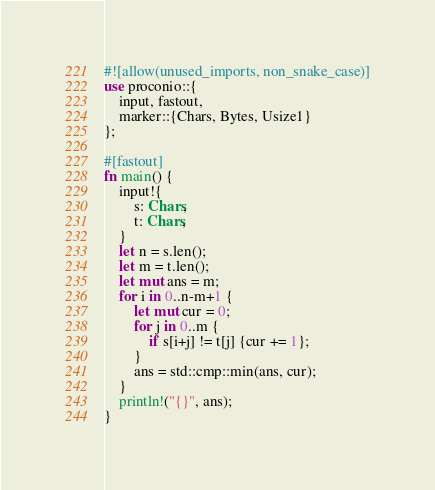<code> <loc_0><loc_0><loc_500><loc_500><_Rust_>#![allow(unused_imports, non_snake_case)]
use proconio::{
    input, fastout,
    marker::{Chars, Bytes, Usize1}
};

#[fastout]
fn main() {
    input!{
        s: Chars,
        t: Chars,
    }
    let n = s.len();
    let m = t.len();
    let mut ans = m;
    for i in 0..n-m+1 {
        let mut cur = 0;
        for j in 0..m {
            if s[i+j] != t[j] {cur += 1};
        }
        ans = std::cmp::min(ans, cur);
    }
    println!("{}", ans);
}
</code> 